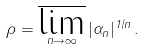Convert formula to latex. <formula><loc_0><loc_0><loc_500><loc_500>\rho = \varlimsup _ { n \to \infty } | \alpha _ { n } | ^ { 1 / n } \, .</formula> 